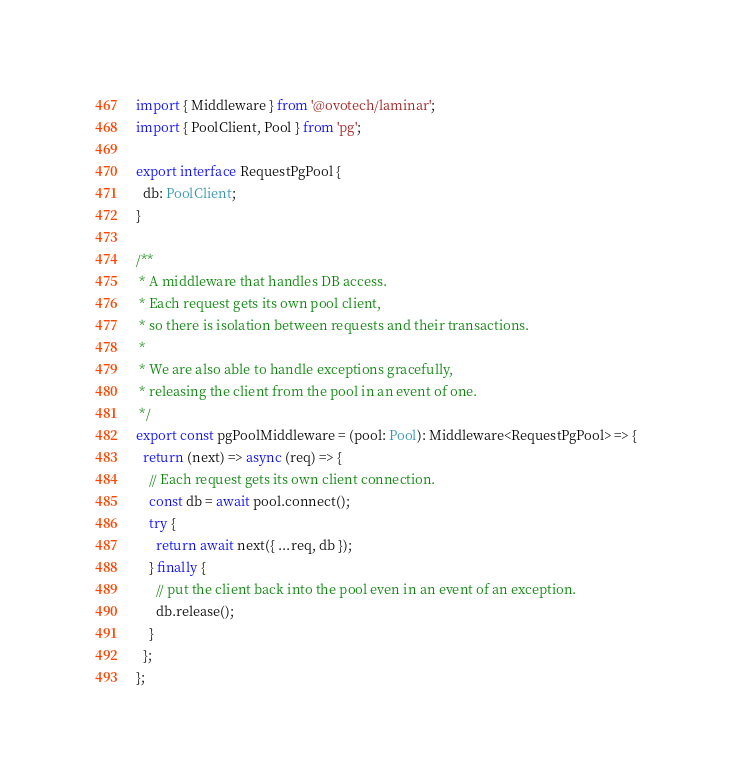Convert code to text. <code><loc_0><loc_0><loc_500><loc_500><_TypeScript_>import { Middleware } from '@ovotech/laminar';
import { PoolClient, Pool } from 'pg';

export interface RequestPgPool {
  db: PoolClient;
}

/**
 * A middleware that handles DB access.
 * Each request gets its own pool client,
 * so there is isolation between requests and their transactions.
 *
 * We are also able to handle exceptions gracefully,
 * releasing the client from the pool in an event of one.
 */
export const pgPoolMiddleware = (pool: Pool): Middleware<RequestPgPool> => {
  return (next) => async (req) => {
    // Each request gets its own client connection.
    const db = await pool.connect();
    try {
      return await next({ ...req, db });
    } finally {
      // put the client back into the pool even in an event of an exception.
      db.release();
    }
  };
};
</code> 